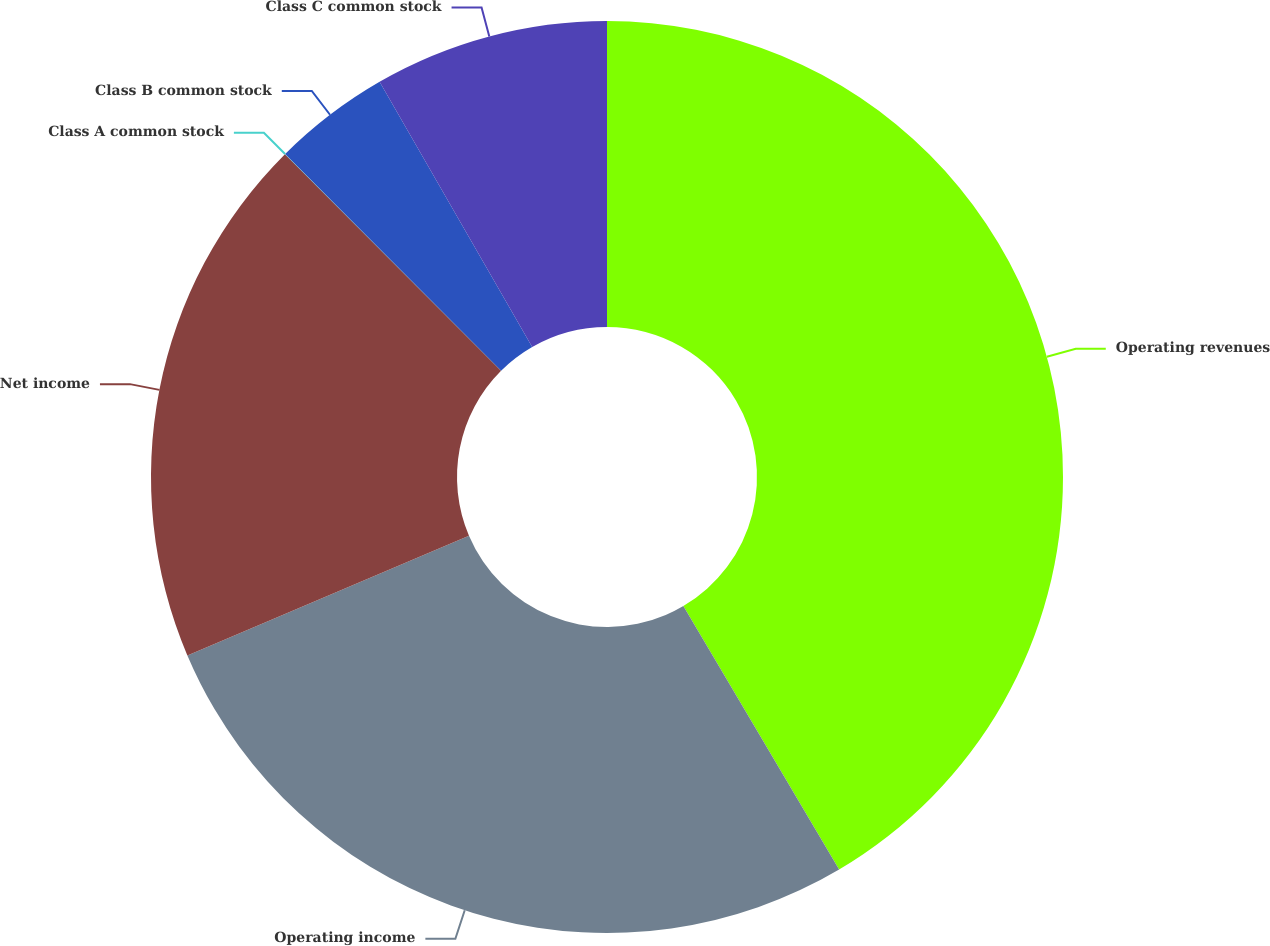Convert chart to OTSL. <chart><loc_0><loc_0><loc_500><loc_500><pie_chart><fcel>Operating revenues<fcel>Operating income<fcel>Net income<fcel>Class A common stock<fcel>Class B common stock<fcel>Class C common stock<nl><fcel>41.5%<fcel>27.1%<fcel>18.92%<fcel>0.01%<fcel>4.16%<fcel>8.31%<nl></chart> 